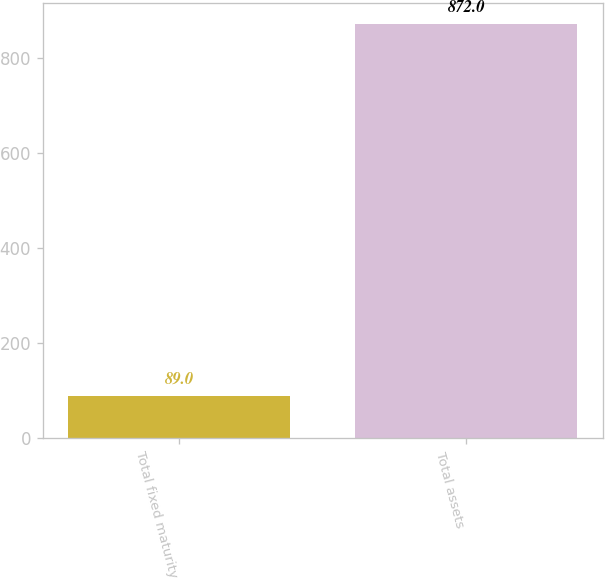Convert chart to OTSL. <chart><loc_0><loc_0><loc_500><loc_500><bar_chart><fcel>Total fixed maturity<fcel>Total assets<nl><fcel>89<fcel>872<nl></chart> 